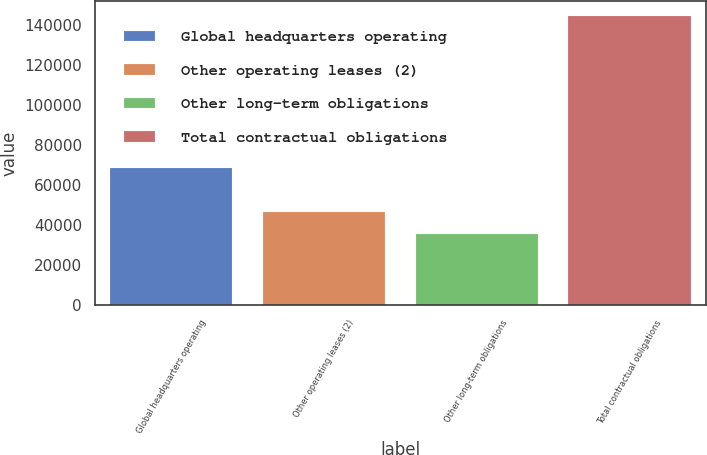<chart> <loc_0><loc_0><loc_500><loc_500><bar_chart><fcel>Global headquarters operating<fcel>Other operating leases (2)<fcel>Other long-term obligations<fcel>Total contractual obligations<nl><fcel>68389<fcel>46370.2<fcel>35463<fcel>144535<nl></chart> 